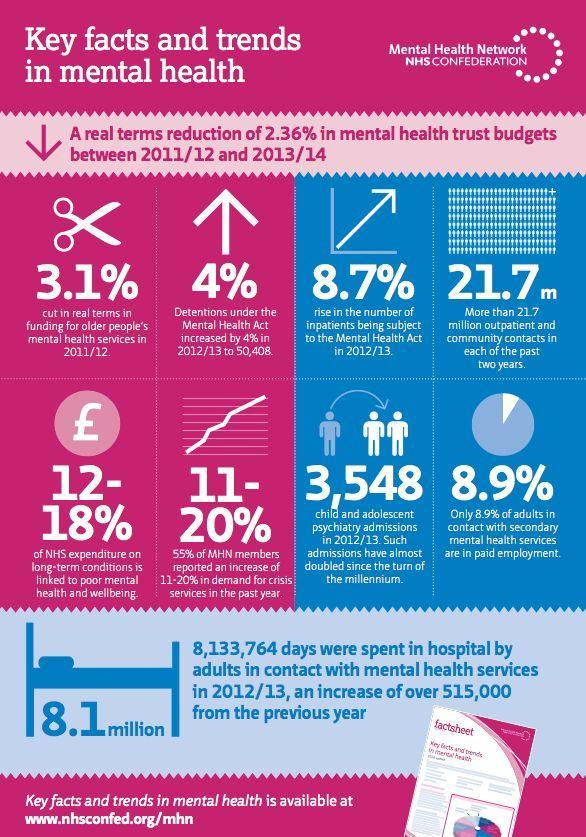what has been the increase of inpatients being subject to the Mental Health Act in 2012/13
Answer the question with a short phrase. 8.7% How many days were spent in hospital by adults in contact with mental health services in 2011/12 7618764 how much as been the child and adolescent psychiatry admissions 3,548 how much of NHS expenditure on long-terms conditions is linked to poor mental health and wellbeing 12-18% 